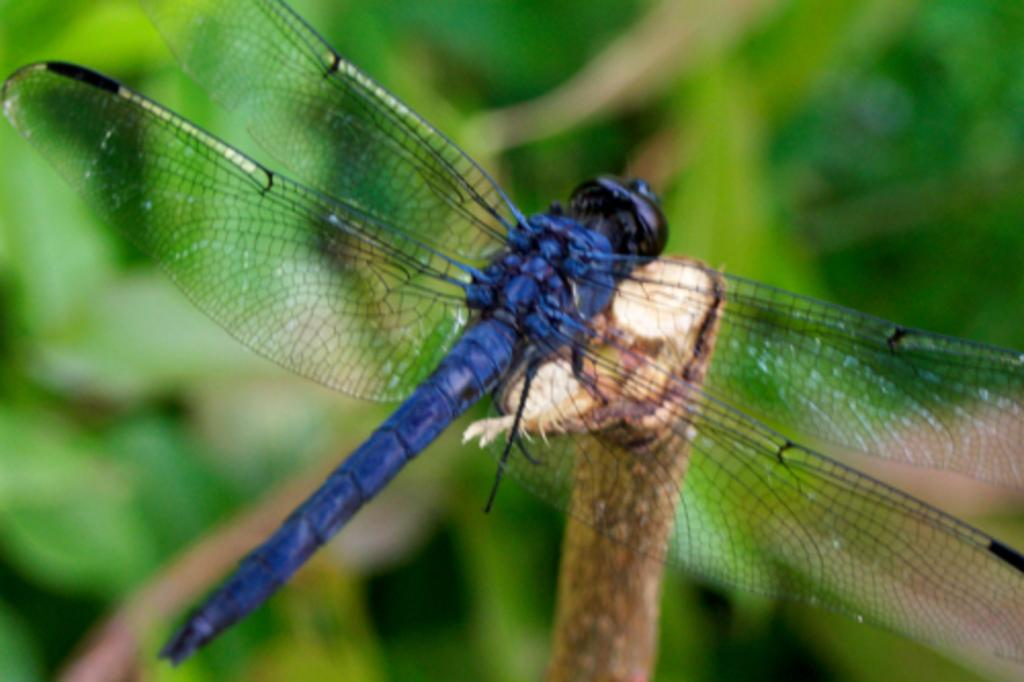What insect is present in the image? There is a dragonfly in the image. Where is the dragonfly located? The dragonfly is on a stem. How would you describe the appearance of the background in the image? The background appears blurred. What color is the background in the image? The background is green in color. How many pancakes are stacked on the sheep in the image? There are no pancakes or sheep present in the image; it features a dragonfly on a stem with a blurred green background. 